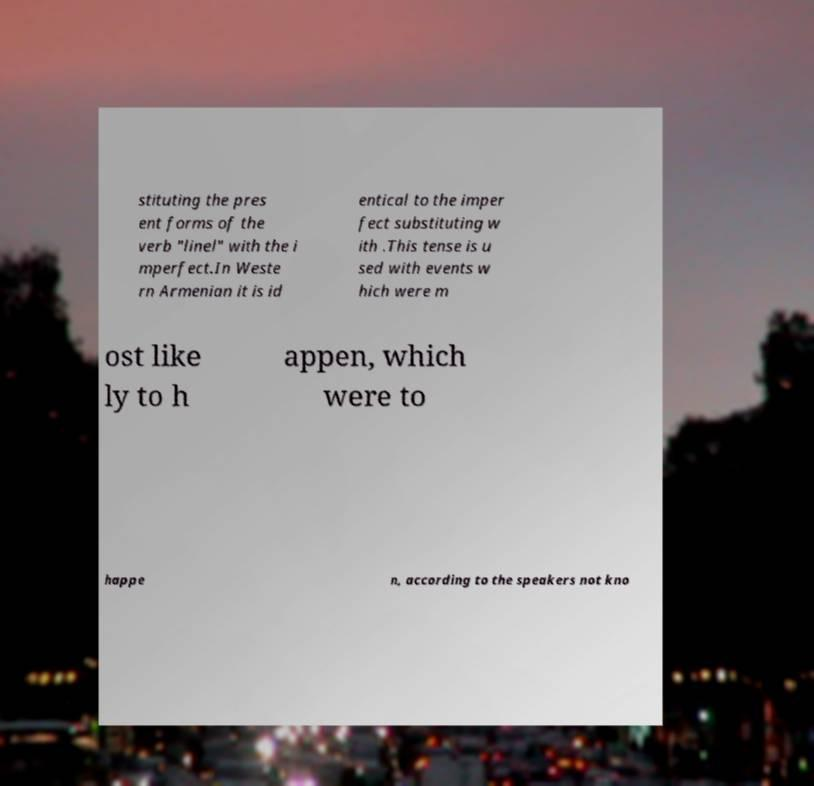Could you assist in decoding the text presented in this image and type it out clearly? stituting the pres ent forms of the verb "linel" with the i mperfect.In Weste rn Armenian it is id entical to the imper fect substituting w ith .This tense is u sed with events w hich were m ost like ly to h appen, which were to happe n, according to the speakers not kno 